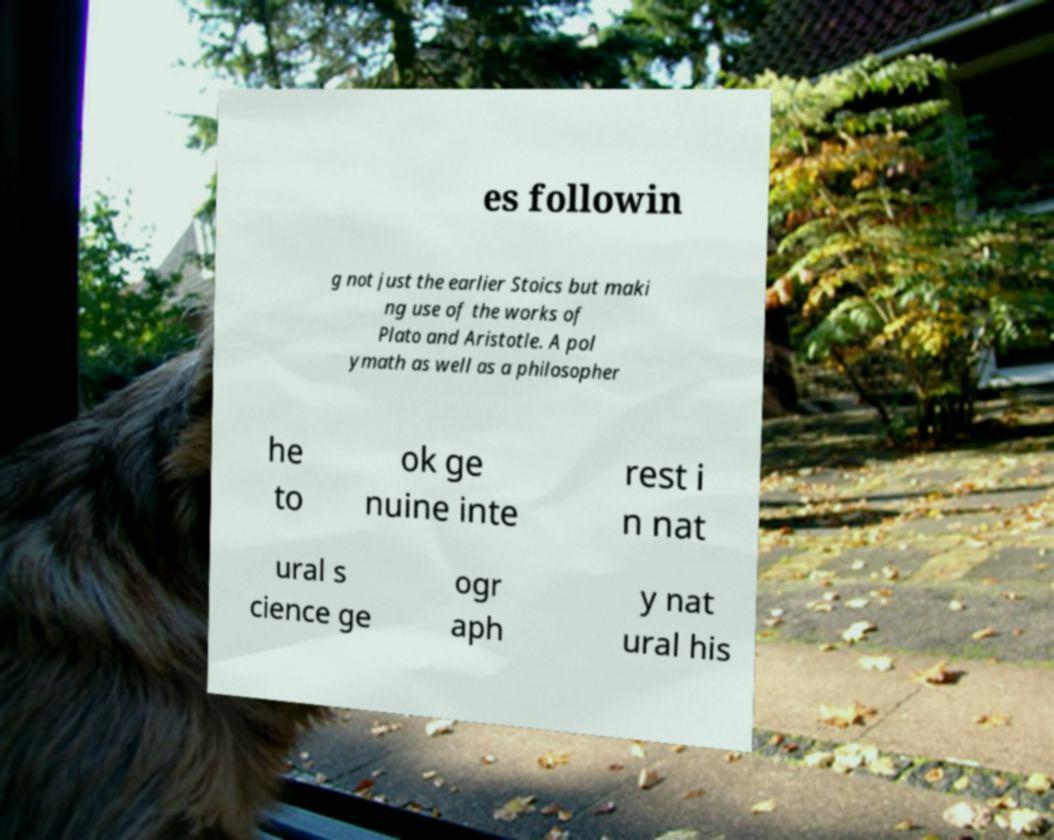Please identify and transcribe the text found in this image. es followin g not just the earlier Stoics but maki ng use of the works of Plato and Aristotle. A pol ymath as well as a philosopher he to ok ge nuine inte rest i n nat ural s cience ge ogr aph y nat ural his 